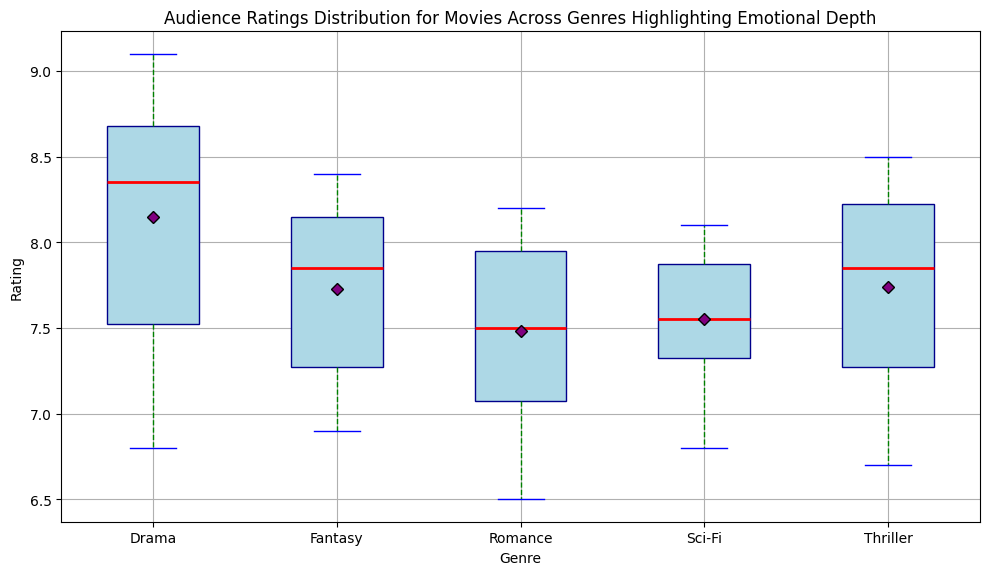What is the median rating for Drama movies? The red line inside the Drama box represents the median rating. By observing the boxplot, we can see that the median is at 8.2.
Answer: 8.2 Which genre has the highest median rating? Each genre's median rating is represented by a red line inside the box. By comparing these lines across all genres, we see that the Drama and Fantasy genres have the highest median ratings, but Drama is slightly higher.
Answer: Drama Which genre has the widest range of ratings? The range of ratings for each genre is depicted by the length of the whiskers (vertical lines) that extend from the box. Drama has the widest range as its whiskers are spread out the most, from roughly 6.8 to 9.1.
Answer: Drama What is the mean rating for Sci-Fi movies? The mean rating is displayed as a purple diamond shape within the boxplot. For Sci-Fi movies, the purple diamond is located around 7.5.
Answer: Around 7.5 How do the median ratings of Romance and Thriller compare? The red lines indicate the median ratings. By comparing the lines for Romance and Thriller, we see that the median rating for Romance is slightly lower than that of Thriller.
Answer: Romance is slightly lower Which genre has the least variability in ratings? Variability can be assessed by the interquartile range (IQR), which is the height of the box. Thriller has the shortest box, indicating the least variability in ratings.
Answer: Thriller Are there any genres with outlier ratings? Outliers are indicated by orange circles outside the whiskers. By looking at the boxplot, no genres show orange circles, meaning there are no outliers.
Answer: No Compare the mean ratings of Drama and Fantasy genres. The mean rating is shown by the purple diamond. By comparing these shapes for Drama and Fantasy, we find that the mean rating for Drama is slightly higher than Fantasy.
Answer: Drama is slightly higher What is the minimum rating for Romance movies? The lower whisker represents the minimum rating. For Romance, the whisker reaches down to 6.5.
Answer: 6.5 Which genres have mean ratings above 8.0? The mean rating is indicated by purple diamonds. For Drama and Fantasy, the purple diamonds are above 8.0.
Answer: Drama and Fantasy 